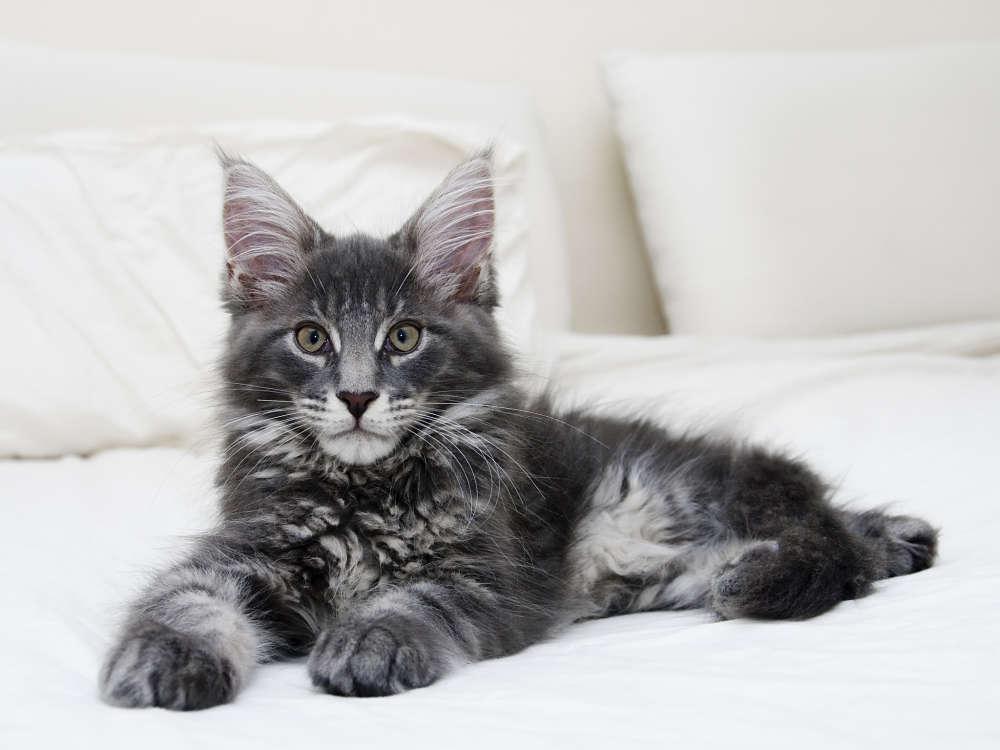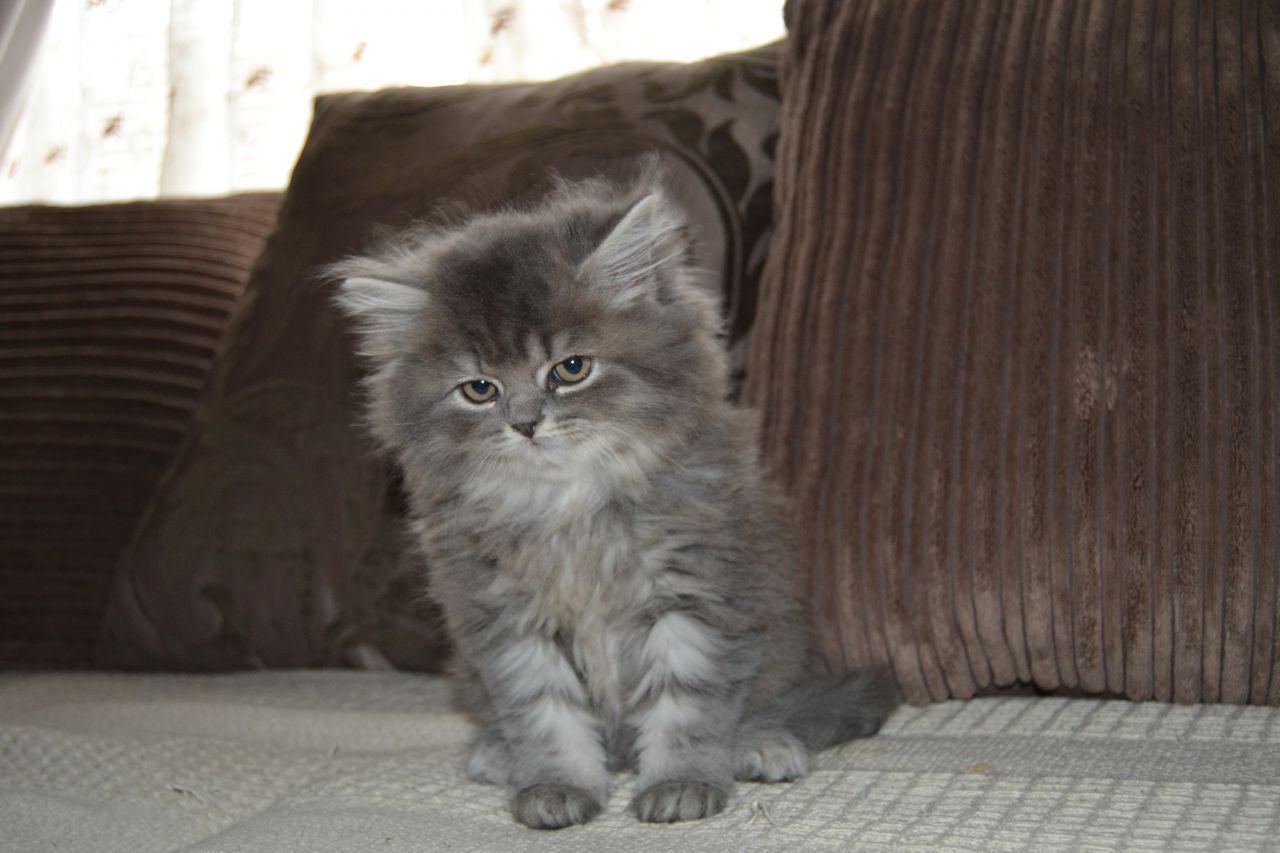The first image is the image on the left, the second image is the image on the right. Given the left and right images, does the statement "The left image shows a cat with open eyes reclining on soft furniture with pillows." hold true? Answer yes or no. Yes. 